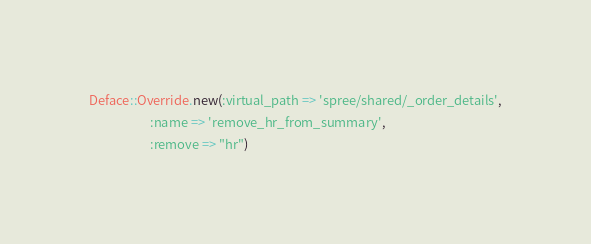Convert code to text. <code><loc_0><loc_0><loc_500><loc_500><_Ruby_>Deface::Override.new(:virtual_path => 'spree/shared/_order_details',
                     :name => 'remove_hr_from_summary',
                     :remove => "hr")
</code> 